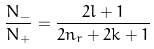Convert formula to latex. <formula><loc_0><loc_0><loc_500><loc_500>\frac { N _ { - } } { N _ { + } } = \frac { 2 l + 1 } { 2 n _ { r } + 2 k + 1 }</formula> 